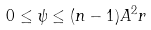Convert formula to latex. <formula><loc_0><loc_0><loc_500><loc_500>0 \leq \psi \leq ( n - 1 ) A ^ { 2 } r</formula> 